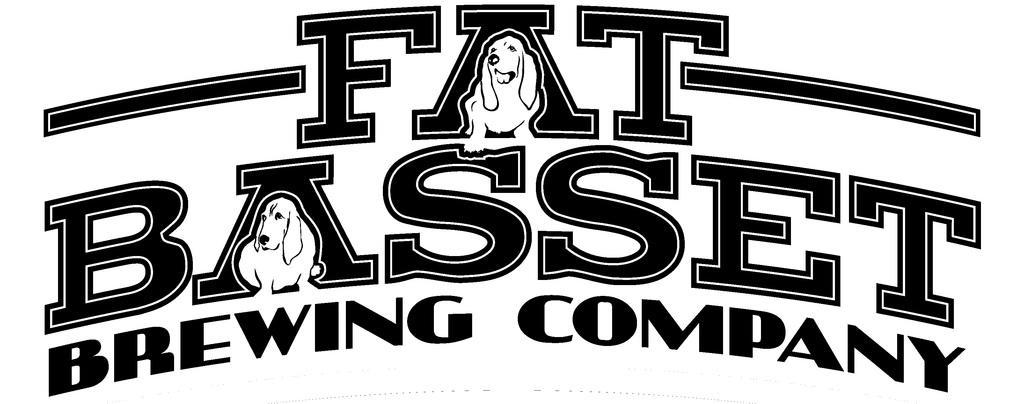Please provide a concise description of this image. In this image in the center there is a text, and there are pictures of dogs and there is white background. 